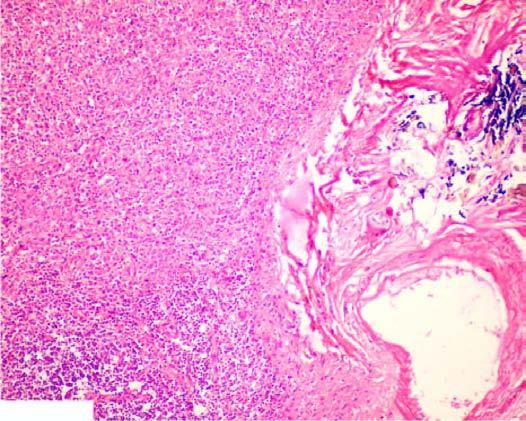s there increased fibrosis in the red pulp, capsule and the trabeculae?
Answer the question using a single word or phrase. Yes 